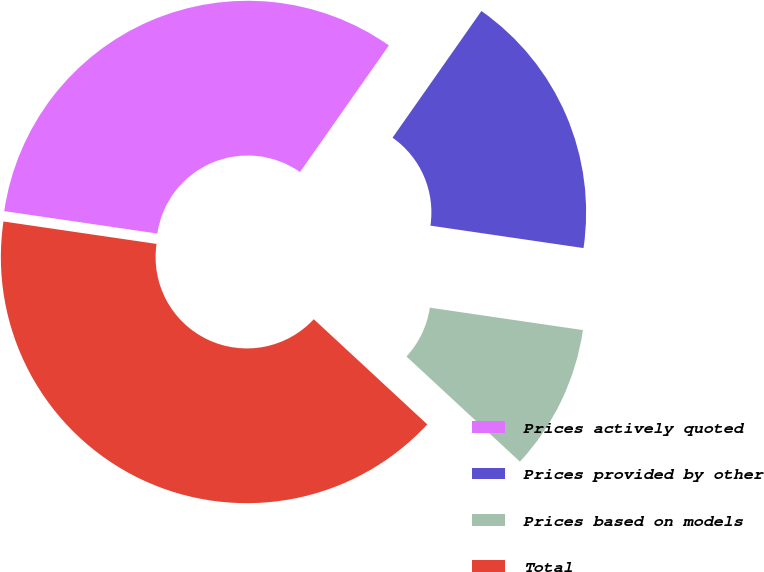<chart> <loc_0><loc_0><loc_500><loc_500><pie_chart><fcel>Prices actively quoted<fcel>Prices provided by other<fcel>Prices based on models<fcel>Total<nl><fcel>32.42%<fcel>17.58%<fcel>9.58%<fcel>40.42%<nl></chart> 